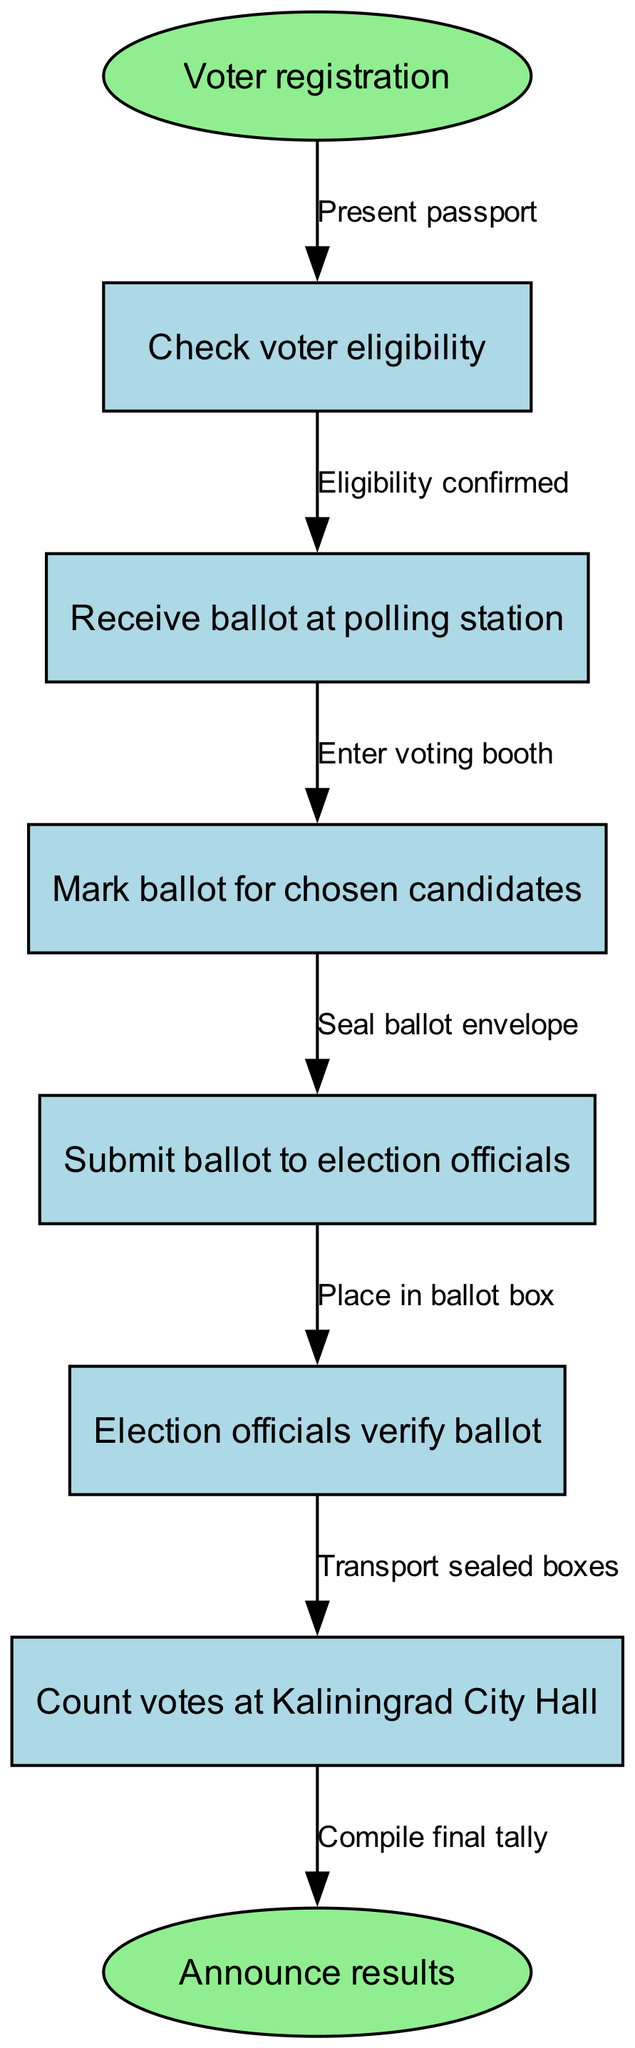What is the first step in the voting process? The first step is "Voter registration." This is indicated by the label on the starting node in the diagram, which outlines the initial action required in the voting process.
Answer: Voter registration How many nodes are present in the diagram? To determine the number of nodes, we can count each unique step listed in the diagram, including the start and end nodes. There are a total of 7 nodes including "start" and "end."
Answer: 7 What does a voter need to present at the beginning of the process? According to the diagram's edge from the starting node, the voter must "Present passport" to initiate the voting process. This is the required identification to begin checking eligibility.
Answer: Present passport Which step follows after confirming eligibility? The next step after "Eligibility confirmed" is "Receive ballot at polling station." The flow of the diagram shows this transition clearly between the two nodes.
Answer: Receive ballot at polling station What is the final action taken before announcing results? The last action before announcing the results is "Count votes at Kaliningrad City Hall." This step is connected directly from the "Verify ballot" node, indicating the final tally process.
Answer: Count votes at Kaliningrad City Hall How does a voter submit their ballot? A voter submits their ballot by placing it "in ballot box." This occurs after sealing the ballot envelope, as indicated in the flow of the diagram.
Answer: Place in ballot box What action does a voter take after marking their ballot? After marking their ballot for chosen candidates, the voter must "Seal ballot envelope." This action is a direct step in the diagram that leads to the submission of their ballot.
Answer: Seal ballot envelope What is the relationship between marking the ballot and submitting it? The relationship is that after the ballot is marked, the next action is to seal the ballot envelope before submission. This stepwise connection is represented by the edge linking the two nodes.
Answer: Seal ballot envelope What occurs if a voter's eligibility is not confirmed? If a voter's eligibility is not confirmed, they cannot proceed to receive a ballot. The flowchart implies that the process cannot advance unless this eligibility check is passed.
Answer: Process halts 